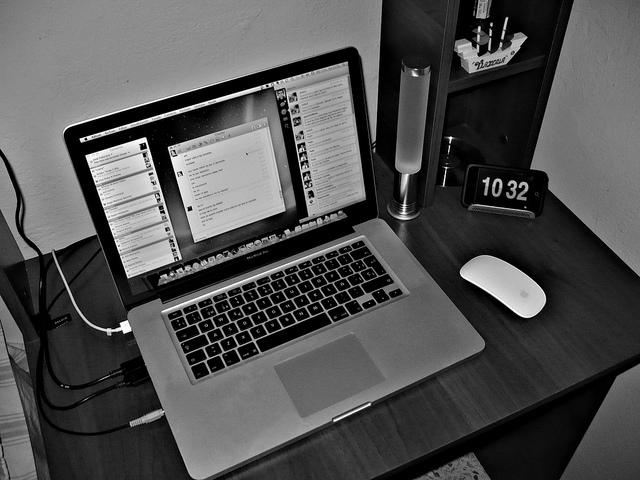Is this photo in color?
Answer briefly. No. Is the laptop on?
Answer briefly. Yes. Is this computer screen on?
Write a very short answer. Yes. What color is the light on the keyboard?
Give a very brief answer. White. Where is the laptop?
Keep it brief. On table. What type of laptop is this?
Short answer required. Lenovo. Is the computer white?
Answer briefly. No. How many surfaces does this desk have?
Keep it brief. 1. What time is it?
Answer briefly. 10:32. Is there a calculator on the table?
Give a very brief answer. No. Is this guitar stuff?
Write a very short answer. No. Is the appliance plugged in?
Quick response, please. Yes. Which keys are the sharp ones?
Give a very brief answer. None. 